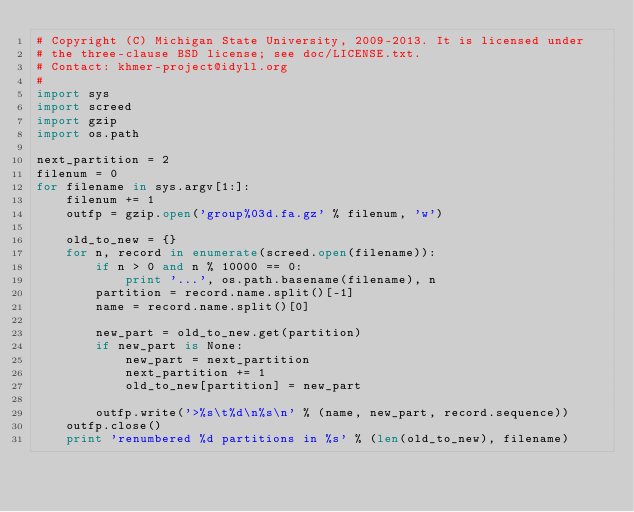<code> <loc_0><loc_0><loc_500><loc_500><_Python_># Copyright (C) Michigan State University, 2009-2013. It is licensed under
# the three-clause BSD license; see doc/LICENSE.txt.
# Contact: khmer-project@idyll.org
#
import sys
import screed
import gzip
import os.path

next_partition = 2
filenum = 0
for filename in sys.argv[1:]:
    filenum += 1
    outfp = gzip.open('group%03d.fa.gz' % filenum, 'w')

    old_to_new = {}
    for n, record in enumerate(screed.open(filename)):
        if n > 0 and n % 10000 == 0:
            print '...', os.path.basename(filename), n
        partition = record.name.split()[-1]
        name = record.name.split()[0]

        new_part = old_to_new.get(partition)
        if new_part is None:
            new_part = next_partition
            next_partition += 1
            old_to_new[partition] = new_part

        outfp.write('>%s\t%d\n%s\n' % (name, new_part, record.sequence))
    outfp.close()
    print 'renumbered %d partitions in %s' % (len(old_to_new), filename)
</code> 